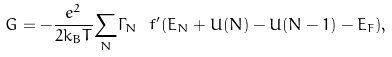<formula> <loc_0><loc_0><loc_500><loc_500>G = - \frac { e ^ { 2 } } { 2 k _ { B } T } \underset { N } { \sum } \Gamma _ { N } \ f ^ { \prime } ( E _ { N } + U ( N ) - U ( N - 1 ) - E _ { F } ) ,</formula> 